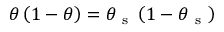Convert formula to latex. <formula><loc_0><loc_0><loc_500><loc_500>\theta \left ( 1 - \theta \right ) = \theta _ { s } \left ( 1 - \theta _ { s } \right )</formula> 